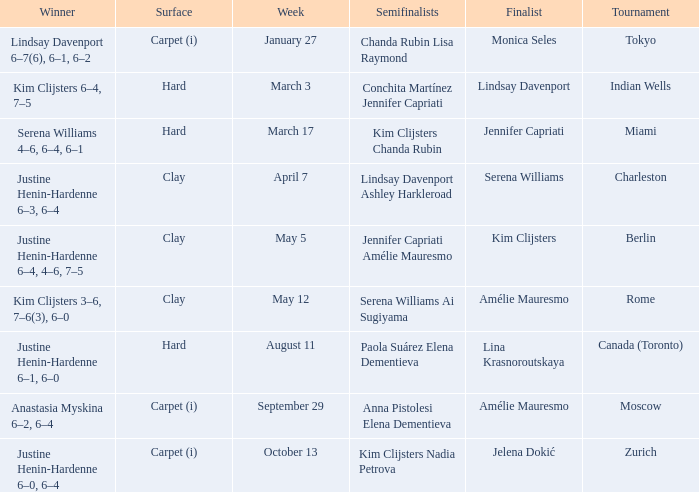Who was the finalist in Miami? Jennifer Capriati. 